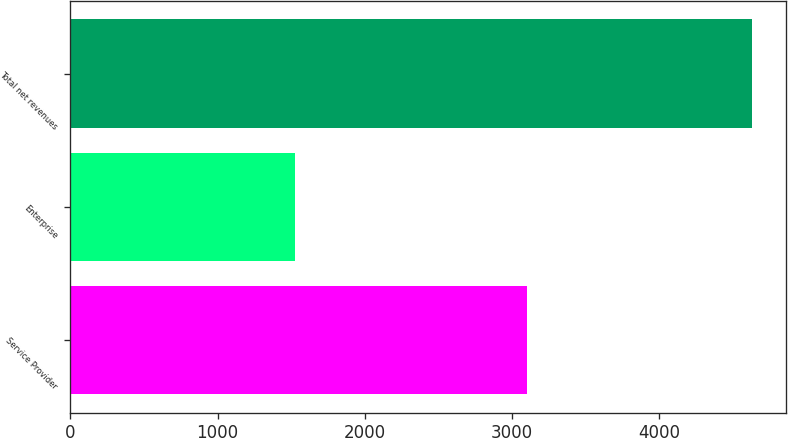<chart> <loc_0><loc_0><loc_500><loc_500><bar_chart><fcel>Service Provider<fcel>Enterprise<fcel>Total net revenues<nl><fcel>3100.4<fcel>1526.7<fcel>4627.1<nl></chart> 